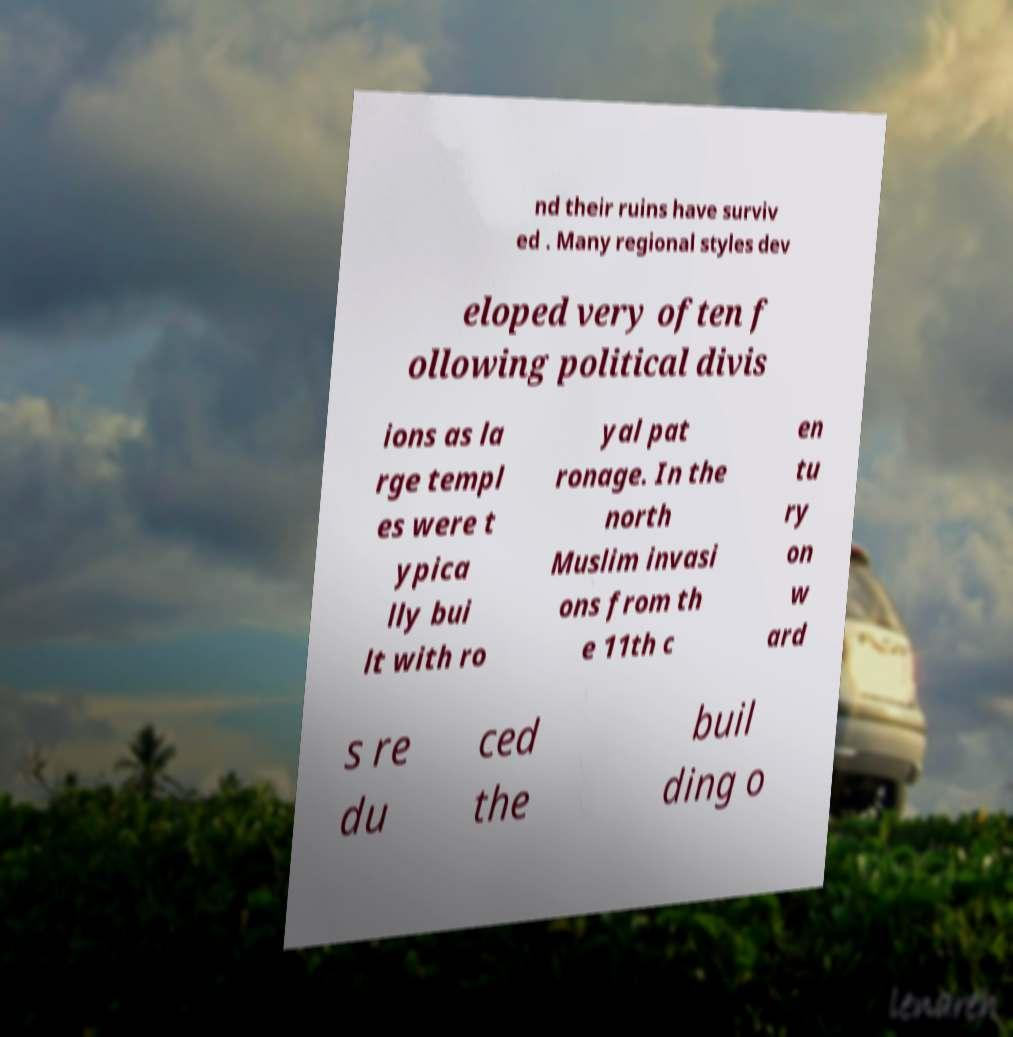I need the written content from this picture converted into text. Can you do that? nd their ruins have surviv ed . Many regional styles dev eloped very often f ollowing political divis ions as la rge templ es were t ypica lly bui lt with ro yal pat ronage. In the north Muslim invasi ons from th e 11th c en tu ry on w ard s re du ced the buil ding o 